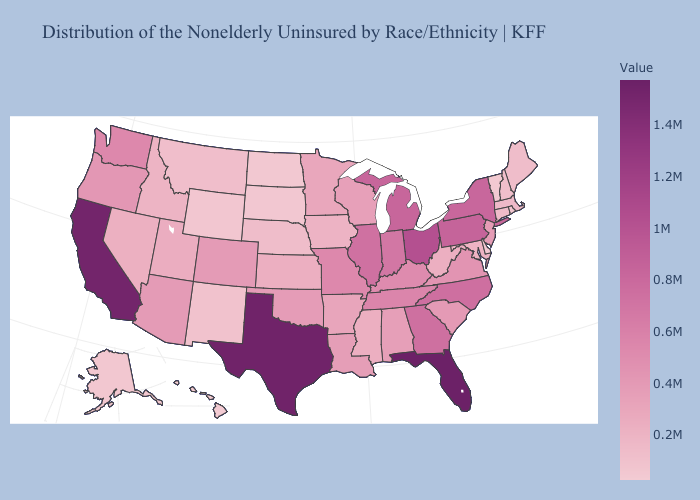Does West Virginia have a higher value than Texas?
Short answer required. No. Does Indiana have a lower value than Minnesota?
Short answer required. No. Which states have the highest value in the USA?
Answer briefly. Florida. Does the map have missing data?
Write a very short answer. No. Among the states that border Colorado , does Arizona have the highest value?
Quick response, please. Yes. Does the map have missing data?
Write a very short answer. No. Does Florida have the highest value in the South?
Write a very short answer. Yes. Which states hav the highest value in the MidWest?
Short answer required. Ohio. 